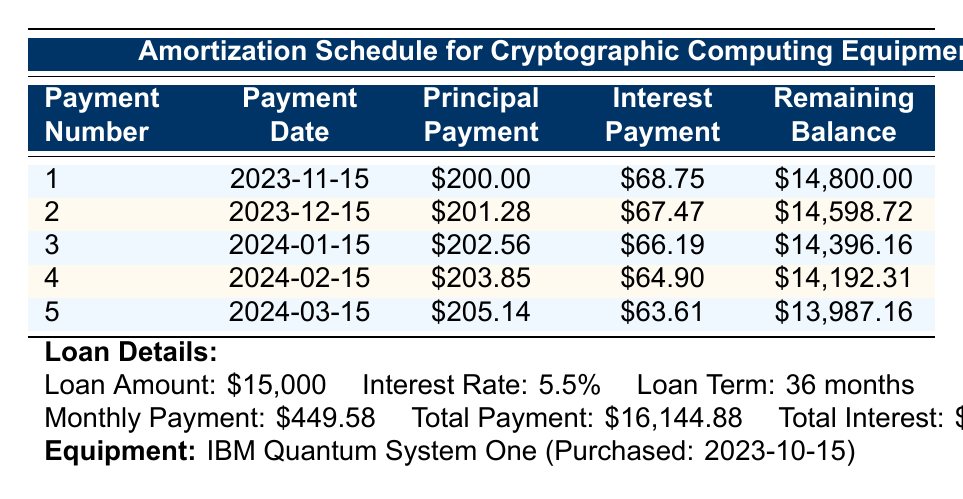What is the loan amount for the cryptographic computing equipment? The loan amount is explicitly stated in the loan details section of the table, which is $15,000.
Answer: 15000 What is the interest rate for the loan? The interest rate is provided in the loan details section of the table, which is 5.5%.
Answer: 5.5% What was the principal payment in the first month? The principal payment for the first month is found in the repayment schedule under payment number 1, which amounts to $200.00.
Answer: 200.00 What is the remaining balance after the second payment? To find the remaining balance after the second payment, we look at the repayment schedule under payment number 2, which indicates the balance is $14,598.72.
Answer: 14598.72 What is the total interest paid over the loan term? The total interest paid is clearly stated in the loan details section of the table and is calculated to be $1,144.88 for the entire loan term.
Answer: 1144.88 Is the principal payment increasing with each payment? Yes, by examining the principal payments from the repayment schedule, we see they are increasing from $200.00 in the first payment to $205.14 in the fifth payment.
Answer: Yes What is the average monthly principal payment over the first five months? To calculate the average monthly principal payment for the first five months, we add all principal payments: 200.00 + 201.28 + 202.56 + 203.85 + 205.14 = 1,012.83. Then, we divide this sum by 5, resulting in an average of about $202.57.
Answer: 202.57 How much total will be paid for the loan including interest? The total payment can be found in the loan details section as $16,144.88, which has already accounted for both principal and interest over the loan term.
Answer: 16144.88 What is the date of the final payment? To find the final payment date, we need to understand that the loan term is 36 months starting from the first payment date of November 15, 2023. Therefore, the final payment date will be November 15, 2026.
Answer: November 15, 2026 